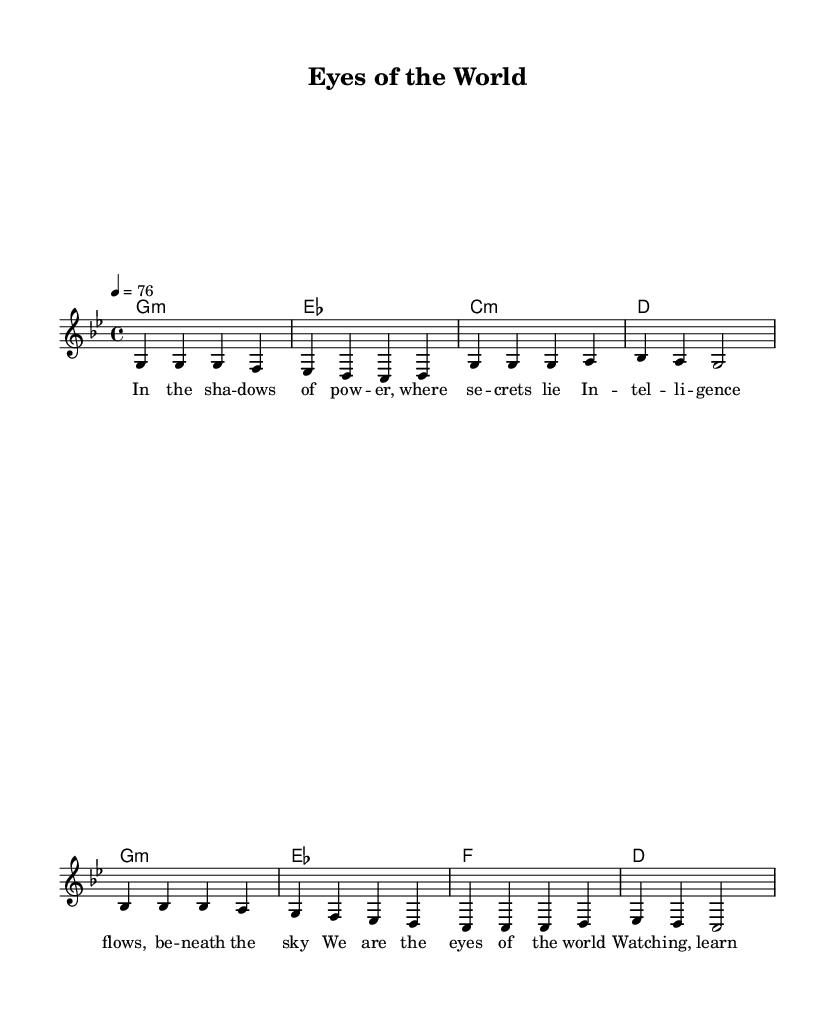What is the key signature of this music? The key signature is G minor, which contains two flats (B flat and E flat).
Answer: G minor What is the time signature of the piece? The time signature shown at the beginning is 4/4, indicating four beats per measure.
Answer: 4/4 What is the tempo marking for the music? The tempo marking specifies that the piece should be played at a tempo of 76 beats per minute.
Answer: 76 How many measures are in the verse? Counting the measures in the verse section, there are 4 measures present.
Answer: 4 How many chords are used in the chorus? The chorus features 4 unique chords: G minor, E flat, F, and D.
Answer: 4 What is the lyrical theme of the song? The lyrics imply a theme of awareness and vigilance regarding global power dynamics and intelligence.
Answer: Awareness What style of music does this piece represent? The style of music represented is conscious reggae, emphasizing social and political consciousness.
Answer: Conscious reggae 